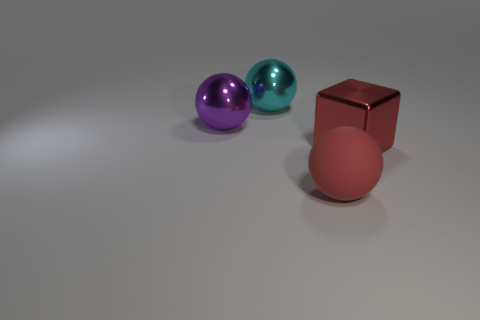Add 3 big green objects. How many objects exist? 7 Subtract all spheres. How many objects are left? 1 Subtract all big metal spheres. Subtract all small cyan rubber cylinders. How many objects are left? 2 Add 2 red blocks. How many red blocks are left? 3 Add 3 large metal objects. How many large metal objects exist? 6 Subtract 0 brown cylinders. How many objects are left? 4 